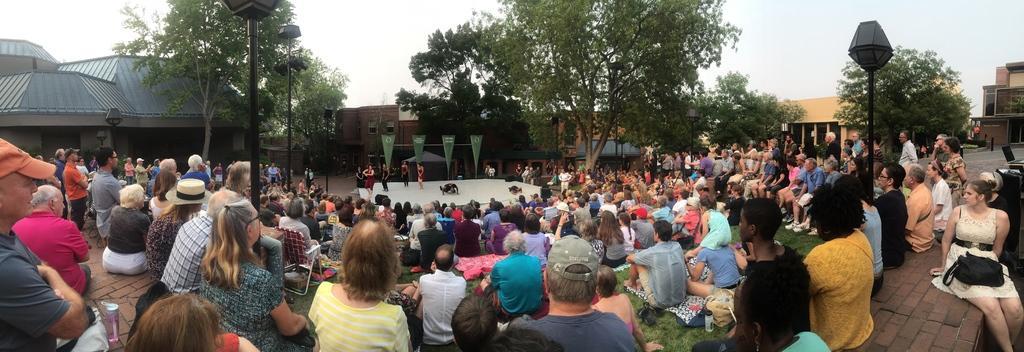In one or two sentences, can you explain what this image depicts? In this image we can see a few people, some of them are on the stage, there are banners with text on it, there are bags, bottles, on the ground, there are light poles, there are buildings, also we can see the sky. 